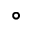<formula> <loc_0><loc_0><loc_500><loc_500>^ { \circ }</formula> 